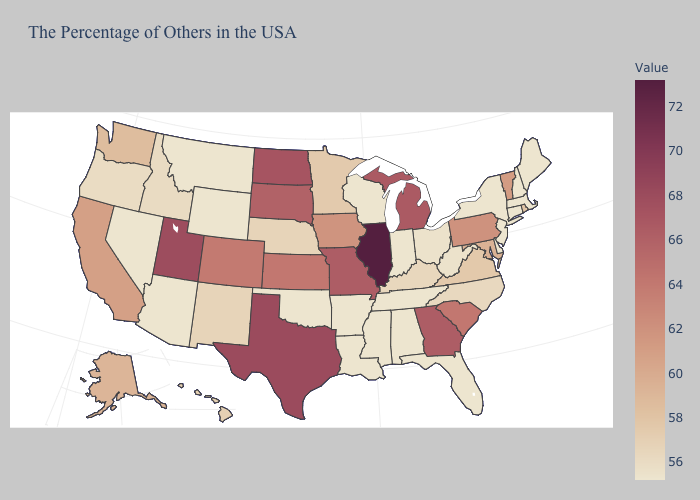Does Illinois have the highest value in the USA?
Short answer required. Yes. Among the states that border New York , which have the lowest value?
Quick response, please. Massachusetts, Connecticut, New Jersey. Does South Dakota have the highest value in the USA?
Quick response, please. No. Is the legend a continuous bar?
Write a very short answer. Yes. Does Pennsylvania have a lower value than Idaho?
Keep it brief. No. Does Florida have the lowest value in the USA?
Short answer required. Yes. Which states hav the highest value in the South?
Write a very short answer. Texas. Among the states that border Massachusetts , which have the lowest value?
Keep it brief. New Hampshire, Connecticut, New York. Does Nevada have a lower value than Alaska?
Give a very brief answer. Yes. 